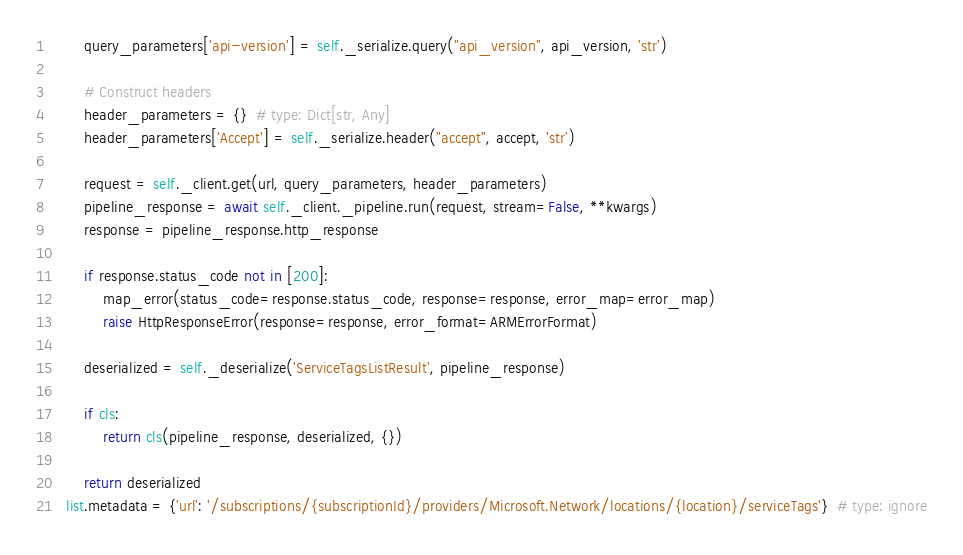Convert code to text. <code><loc_0><loc_0><loc_500><loc_500><_Python_>        query_parameters['api-version'] = self._serialize.query("api_version", api_version, 'str')

        # Construct headers
        header_parameters = {}  # type: Dict[str, Any]
        header_parameters['Accept'] = self._serialize.header("accept", accept, 'str')

        request = self._client.get(url, query_parameters, header_parameters)
        pipeline_response = await self._client._pipeline.run(request, stream=False, **kwargs)
        response = pipeline_response.http_response

        if response.status_code not in [200]:
            map_error(status_code=response.status_code, response=response, error_map=error_map)
            raise HttpResponseError(response=response, error_format=ARMErrorFormat)

        deserialized = self._deserialize('ServiceTagsListResult', pipeline_response)

        if cls:
            return cls(pipeline_response, deserialized, {})

        return deserialized
    list.metadata = {'url': '/subscriptions/{subscriptionId}/providers/Microsoft.Network/locations/{location}/serviceTags'}  # type: ignore
</code> 